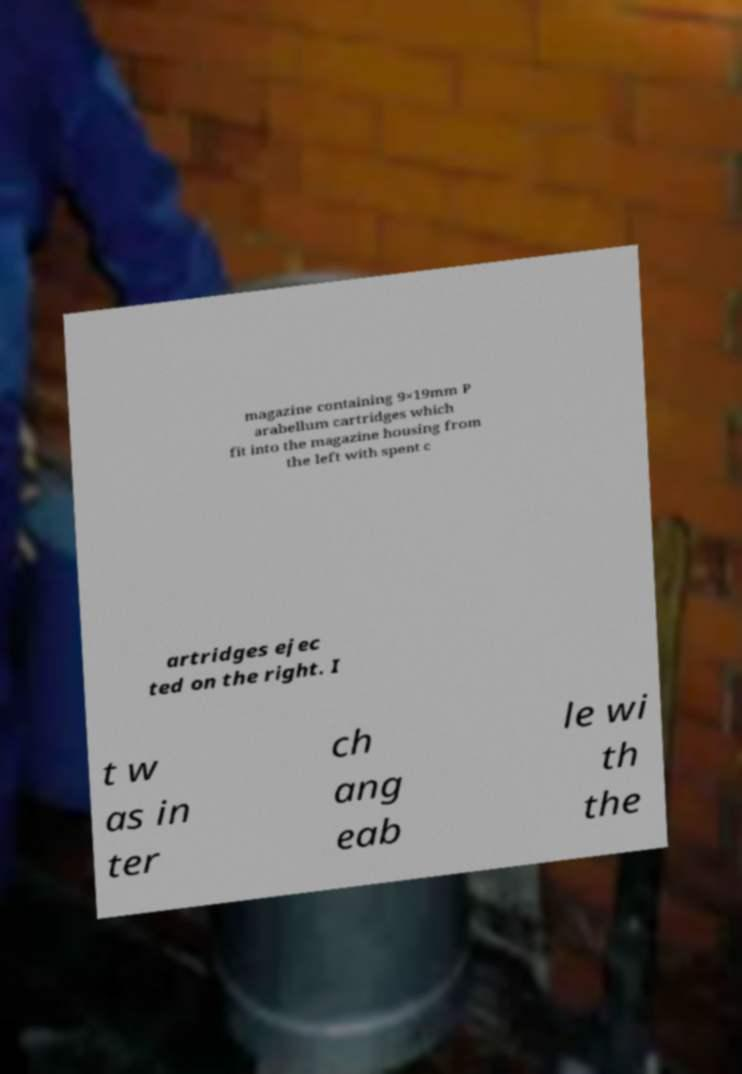Can you read and provide the text displayed in the image?This photo seems to have some interesting text. Can you extract and type it out for me? magazine containing 9×19mm P arabellum cartridges which fit into the magazine housing from the left with spent c artridges ejec ted on the right. I t w as in ter ch ang eab le wi th the 